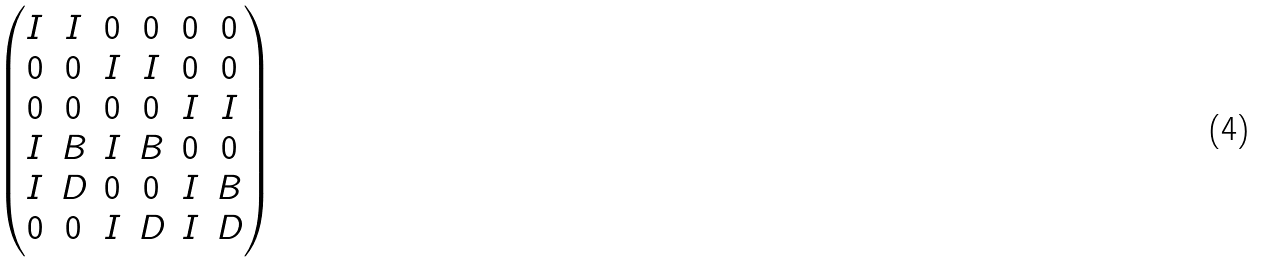<formula> <loc_0><loc_0><loc_500><loc_500>\begin{pmatrix} I & I & 0 & 0 & 0 & 0 \\ 0 & 0 & I & I & 0 & 0 \\ 0 & 0 & 0 & 0 & I & I \\ I & B & I & B & 0 & 0 \\ I & D & 0 & 0 & I & B \\ 0 & 0 & I & D & I & D \end{pmatrix}</formula> 